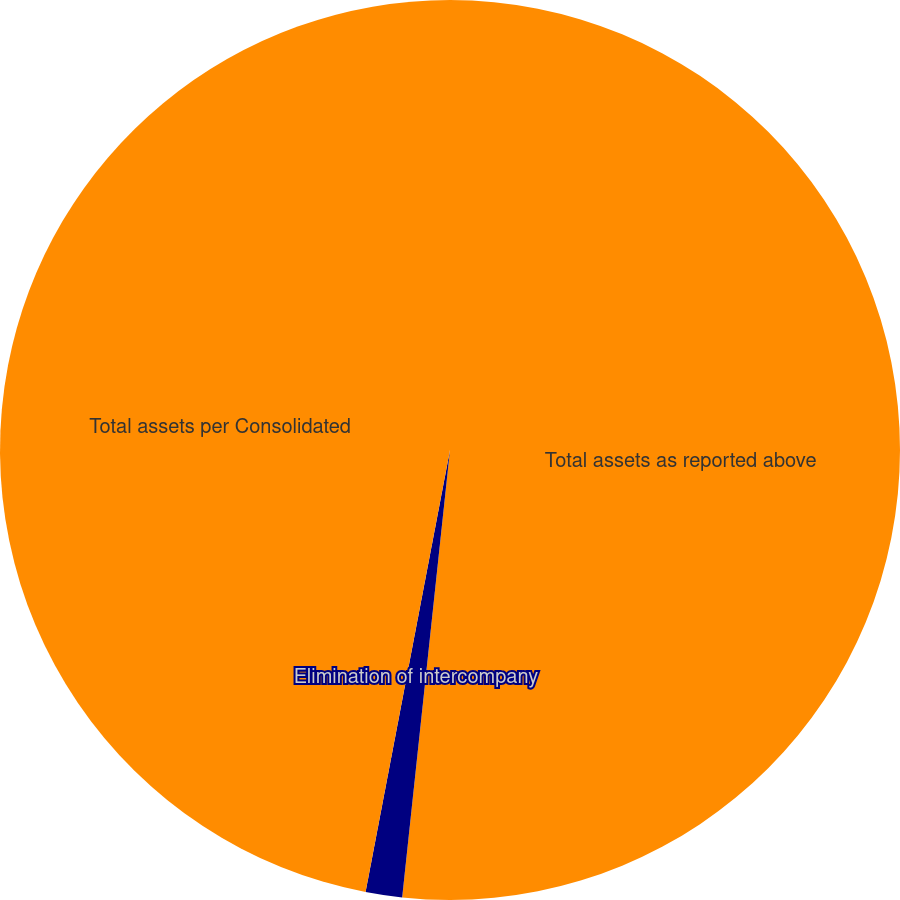Convert chart. <chart><loc_0><loc_0><loc_500><loc_500><pie_chart><fcel>Total assets as reported above<fcel>Elimination of intercompany<fcel>Total assets per Consolidated<nl><fcel>51.7%<fcel>1.31%<fcel>47.0%<nl></chart> 